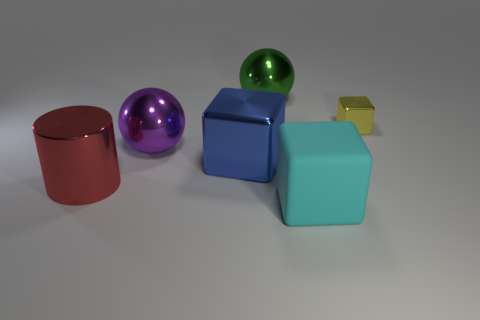Subtract all small blocks. How many blocks are left? 2 Subtract all balls. How many objects are left? 4 Subtract 1 cylinders. How many cylinders are left? 0 Add 1 tiny objects. How many objects exist? 7 Subtract all blue blocks. How many blocks are left? 2 Add 1 tiny yellow metal things. How many tiny yellow metal things are left? 2 Add 4 tiny yellow cylinders. How many tiny yellow cylinders exist? 4 Subtract 0 green blocks. How many objects are left? 6 Subtract all brown cylinders. Subtract all brown cubes. How many cylinders are left? 1 Subtract all cyan blocks. How many purple balls are left? 1 